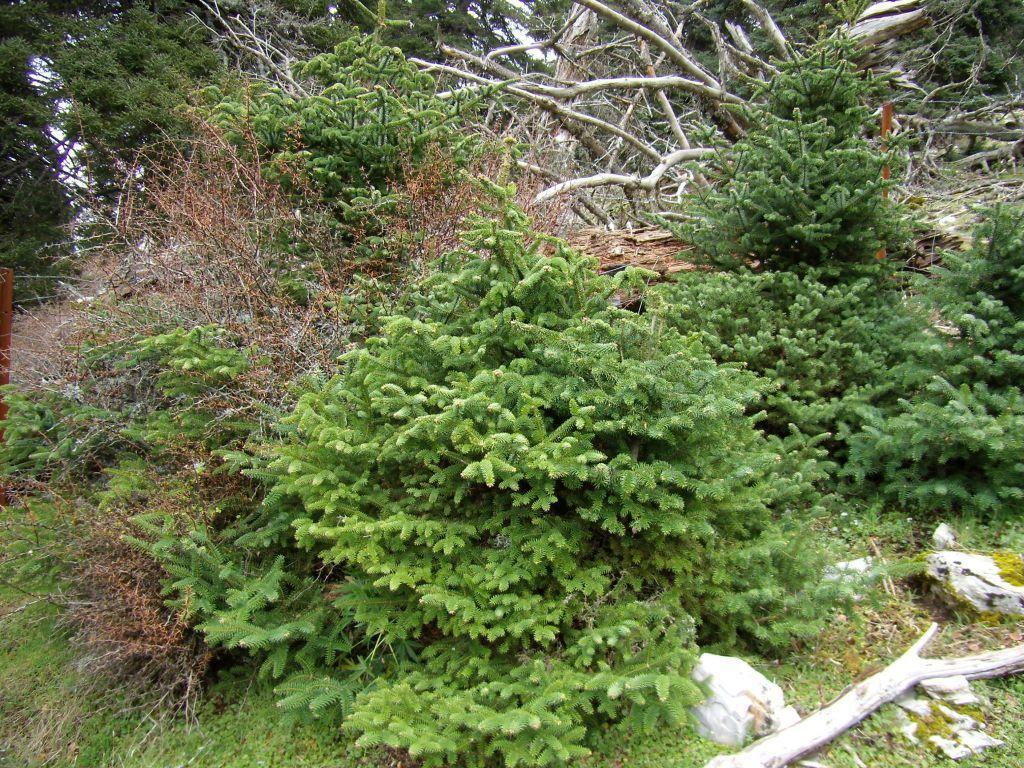Can you describe this image briefly? In this picture I can see many trees, plants and grass. In the bottom right corner I can see some woods and stones. In the background I can see the sky. 